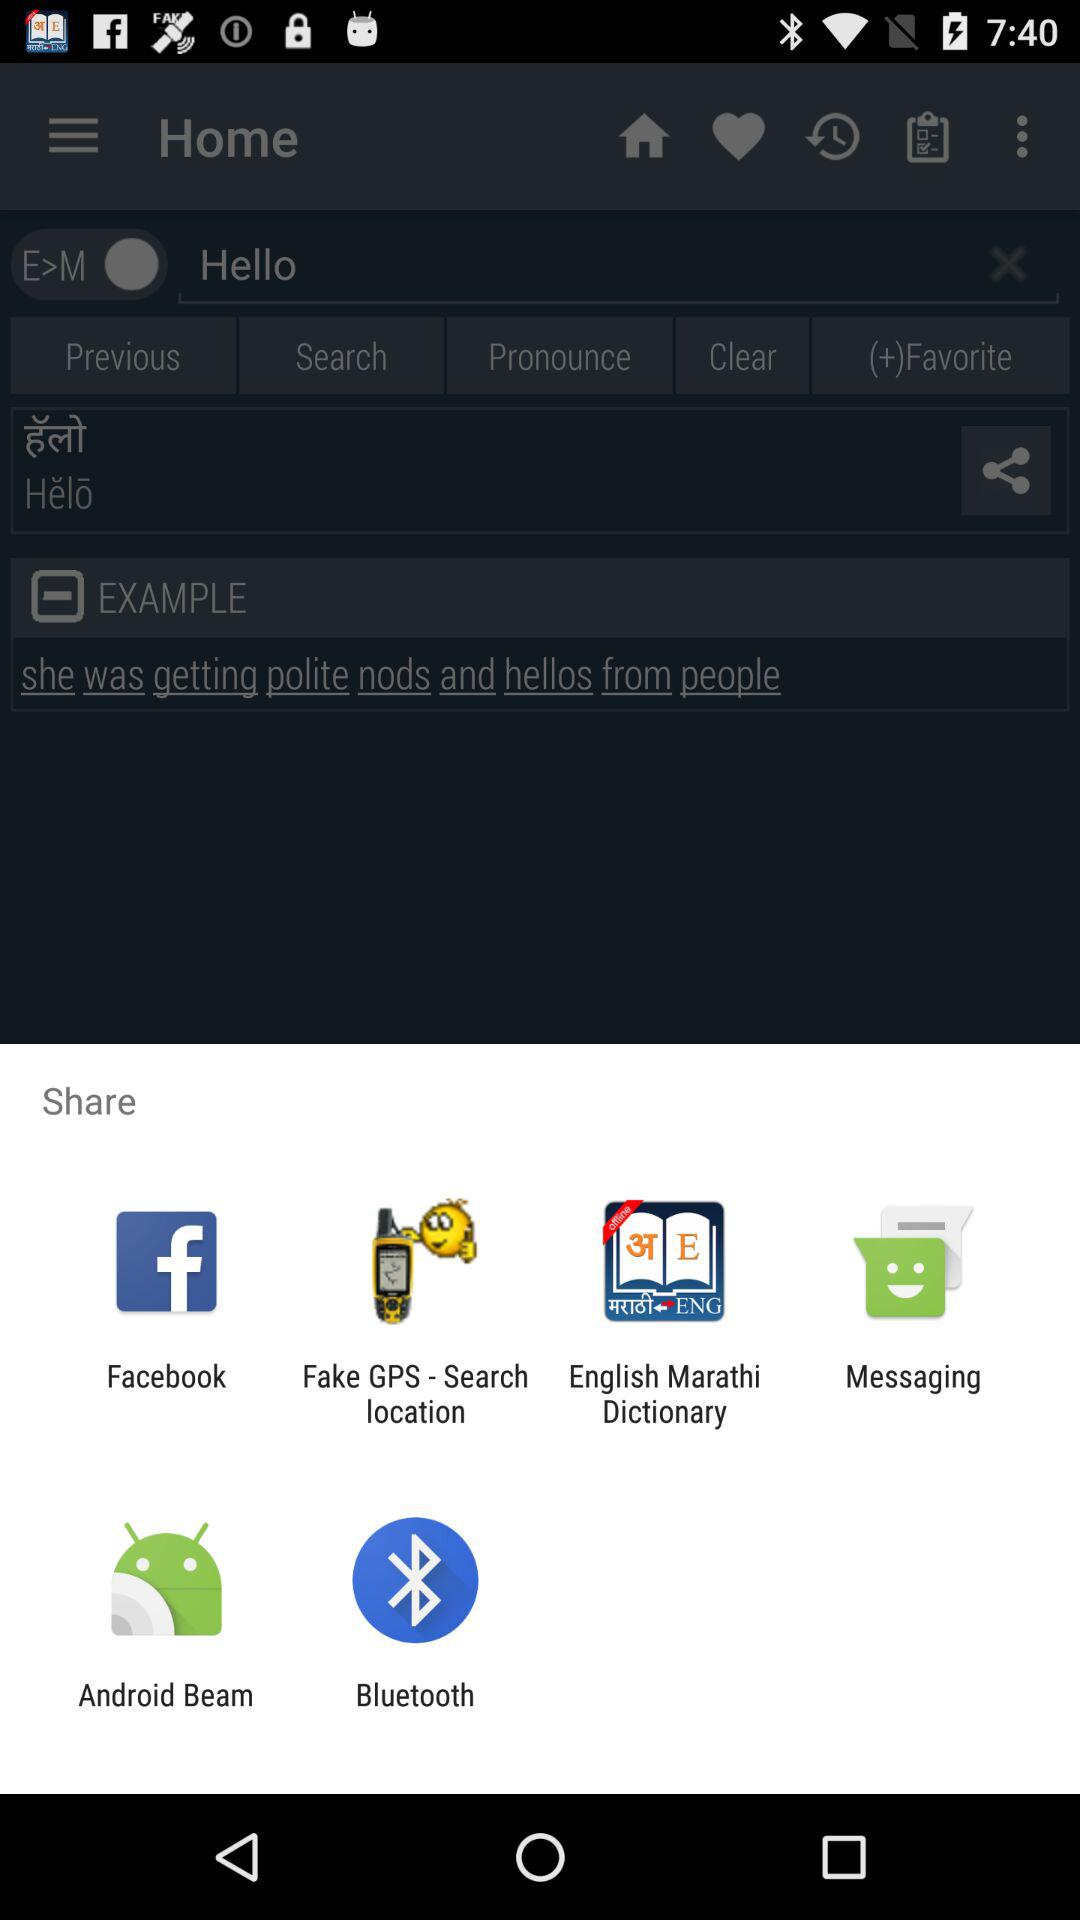How many followers are there?
When the provided information is insufficient, respond with <no answer>. <no answer> 